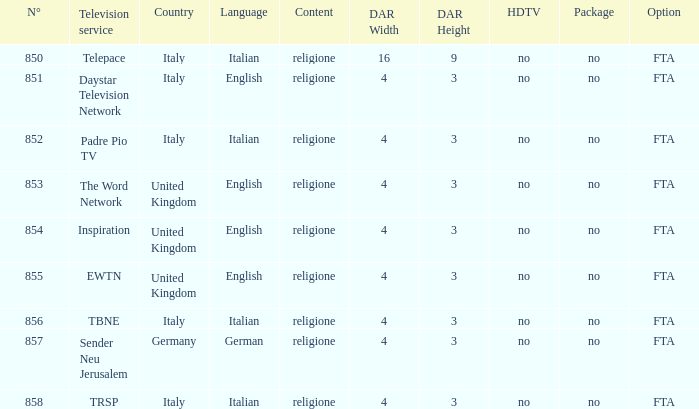What television service are in the united kingdom and n° is greater than 854.0? EWTN. 